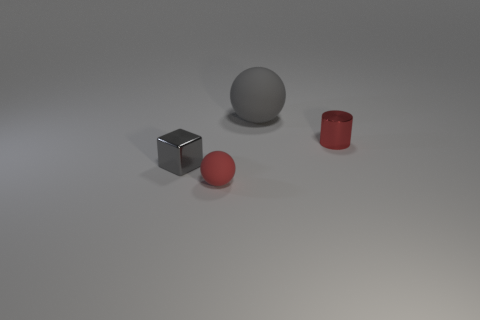Add 4 blue cubes. How many objects exist? 8 Subtract all cubes. How many objects are left? 3 Subtract all red shiny things. Subtract all tiny gray shiny objects. How many objects are left? 2 Add 4 large rubber balls. How many large rubber balls are left? 5 Add 3 gray metallic cubes. How many gray metallic cubes exist? 4 Subtract 0 blue spheres. How many objects are left? 4 